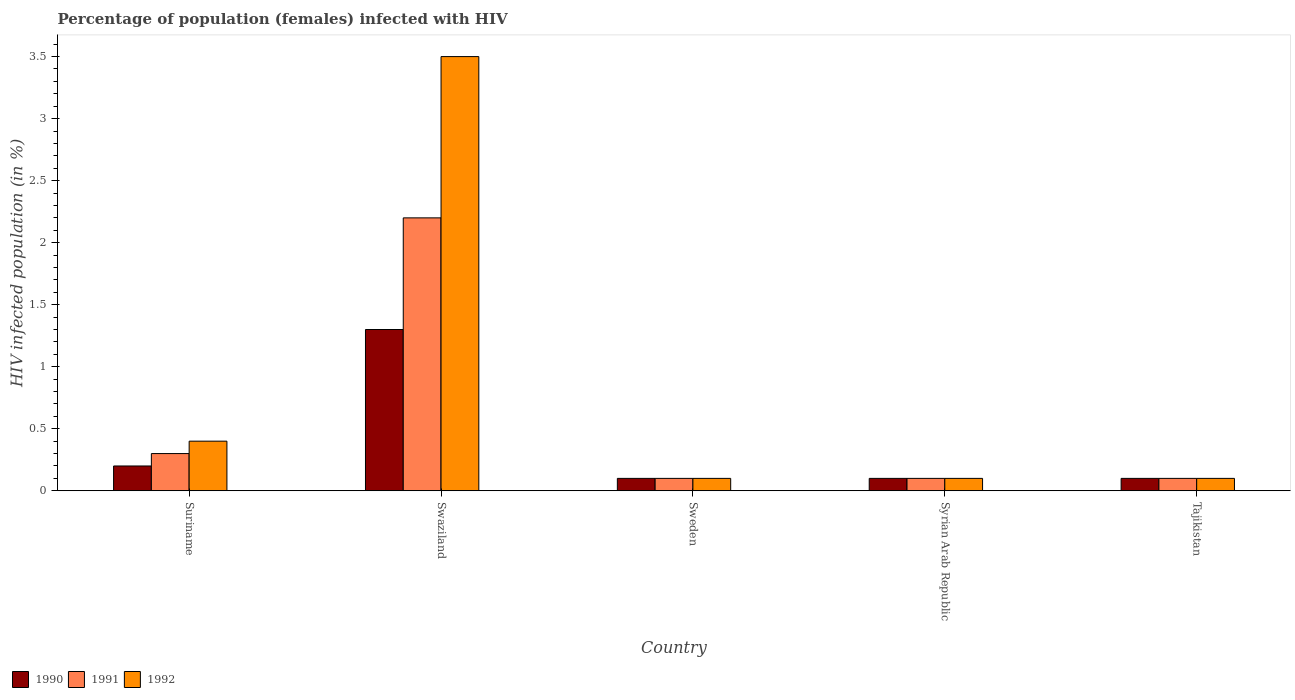How many different coloured bars are there?
Offer a very short reply. 3. How many bars are there on the 2nd tick from the right?
Your response must be concise. 3. What is the label of the 1st group of bars from the left?
Offer a very short reply. Suriname. Across all countries, what is the maximum percentage of HIV infected female population in 1990?
Provide a succinct answer. 1.3. In which country was the percentage of HIV infected female population in 1991 maximum?
Your response must be concise. Swaziland. In which country was the percentage of HIV infected female population in 1990 minimum?
Ensure brevity in your answer.  Sweden. What is the total percentage of HIV infected female population in 1991 in the graph?
Provide a short and direct response. 2.8. What is the average percentage of HIV infected female population in 1991 per country?
Offer a very short reply. 0.56. What is the difference between the percentage of HIV infected female population of/in 1992 and percentage of HIV infected female population of/in 1990 in Sweden?
Provide a succinct answer. 0. In how many countries, is the percentage of HIV infected female population in 1992 greater than 0.9 %?
Provide a short and direct response. 1. Is the percentage of HIV infected female population in 1990 in Sweden less than that in Syrian Arab Republic?
Keep it short and to the point. No. Is the difference between the percentage of HIV infected female population in 1992 in Syrian Arab Republic and Tajikistan greater than the difference between the percentage of HIV infected female population in 1990 in Syrian Arab Republic and Tajikistan?
Offer a terse response. No. What is the difference between the highest and the second highest percentage of HIV infected female population in 1991?
Provide a succinct answer. -1.9. Is the sum of the percentage of HIV infected female population in 1990 in Swaziland and Tajikistan greater than the maximum percentage of HIV infected female population in 1991 across all countries?
Provide a short and direct response. No. What does the 1st bar from the left in Tajikistan represents?
Provide a succinct answer. 1990. What does the 3rd bar from the right in Sweden represents?
Your answer should be compact. 1990. Are all the bars in the graph horizontal?
Your answer should be compact. No. How many countries are there in the graph?
Provide a succinct answer. 5. What is the difference between two consecutive major ticks on the Y-axis?
Provide a short and direct response. 0.5. Does the graph contain any zero values?
Your answer should be compact. No. Where does the legend appear in the graph?
Your response must be concise. Bottom left. How many legend labels are there?
Keep it short and to the point. 3. What is the title of the graph?
Keep it short and to the point. Percentage of population (females) infected with HIV. What is the label or title of the X-axis?
Offer a terse response. Country. What is the label or title of the Y-axis?
Your answer should be compact. HIV infected population (in %). What is the HIV infected population (in %) in 1990 in Suriname?
Your response must be concise. 0.2. What is the HIV infected population (in %) of 1992 in Suriname?
Make the answer very short. 0.4. What is the HIV infected population (in %) in 1992 in Swaziland?
Keep it short and to the point. 3.5. What is the HIV infected population (in %) in 1991 in Sweden?
Your answer should be compact. 0.1. What is the HIV infected population (in %) in 1992 in Sweden?
Your answer should be compact. 0.1. What is the HIV infected population (in %) of 1992 in Syrian Arab Republic?
Provide a succinct answer. 0.1. What is the HIV infected population (in %) of 1990 in Tajikistan?
Keep it short and to the point. 0.1. What is the HIV infected population (in %) in 1992 in Tajikistan?
Provide a short and direct response. 0.1. Across all countries, what is the maximum HIV infected population (in %) of 1992?
Make the answer very short. 3.5. Across all countries, what is the minimum HIV infected population (in %) in 1990?
Make the answer very short. 0.1. Across all countries, what is the minimum HIV infected population (in %) in 1991?
Offer a very short reply. 0.1. What is the total HIV infected population (in %) in 1991 in the graph?
Give a very brief answer. 2.8. What is the total HIV infected population (in %) of 1992 in the graph?
Provide a short and direct response. 4.2. What is the difference between the HIV infected population (in %) of 1992 in Suriname and that in Swaziland?
Ensure brevity in your answer.  -3.1. What is the difference between the HIV infected population (in %) of 1990 in Suriname and that in Sweden?
Your answer should be very brief. 0.1. What is the difference between the HIV infected population (in %) in 1992 in Suriname and that in Sweden?
Make the answer very short. 0.3. What is the difference between the HIV infected population (in %) of 1990 in Suriname and that in Syrian Arab Republic?
Provide a succinct answer. 0.1. What is the difference between the HIV infected population (in %) of 1991 in Suriname and that in Syrian Arab Republic?
Keep it short and to the point. 0.2. What is the difference between the HIV infected population (in %) in 1992 in Suriname and that in Syrian Arab Republic?
Make the answer very short. 0.3. What is the difference between the HIV infected population (in %) of 1990 in Swaziland and that in Sweden?
Your answer should be very brief. 1.2. What is the difference between the HIV infected population (in %) of 1991 in Swaziland and that in Sweden?
Keep it short and to the point. 2.1. What is the difference between the HIV infected population (in %) of 1992 in Swaziland and that in Syrian Arab Republic?
Provide a succinct answer. 3.4. What is the difference between the HIV infected population (in %) in 1991 in Swaziland and that in Tajikistan?
Your response must be concise. 2.1. What is the difference between the HIV infected population (in %) of 1992 in Swaziland and that in Tajikistan?
Your answer should be very brief. 3.4. What is the difference between the HIV infected population (in %) in 1990 in Sweden and that in Syrian Arab Republic?
Keep it short and to the point. 0. What is the difference between the HIV infected population (in %) in 1992 in Sweden and that in Syrian Arab Republic?
Keep it short and to the point. 0. What is the difference between the HIV infected population (in %) of 1990 in Sweden and that in Tajikistan?
Make the answer very short. 0. What is the difference between the HIV infected population (in %) of 1990 in Syrian Arab Republic and that in Tajikistan?
Ensure brevity in your answer.  0. What is the difference between the HIV infected population (in %) in 1990 in Suriname and the HIV infected population (in %) in 1992 in Swaziland?
Your response must be concise. -3.3. What is the difference between the HIV infected population (in %) of 1991 in Suriname and the HIV infected population (in %) of 1992 in Swaziland?
Your response must be concise. -3.2. What is the difference between the HIV infected population (in %) of 1991 in Suriname and the HIV infected population (in %) of 1992 in Sweden?
Provide a short and direct response. 0.2. What is the difference between the HIV infected population (in %) in 1991 in Suriname and the HIV infected population (in %) in 1992 in Tajikistan?
Provide a succinct answer. 0.2. What is the difference between the HIV infected population (in %) in 1990 in Swaziland and the HIV infected population (in %) in 1991 in Sweden?
Make the answer very short. 1.2. What is the difference between the HIV infected population (in %) in 1991 in Swaziland and the HIV infected population (in %) in 1992 in Sweden?
Your response must be concise. 2.1. What is the difference between the HIV infected population (in %) in 1990 in Swaziland and the HIV infected population (in %) in 1992 in Syrian Arab Republic?
Offer a very short reply. 1.2. What is the difference between the HIV infected population (in %) of 1990 in Sweden and the HIV infected population (in %) of 1991 in Syrian Arab Republic?
Your answer should be very brief. 0. What is the difference between the HIV infected population (in %) of 1990 in Sweden and the HIV infected population (in %) of 1992 in Syrian Arab Republic?
Keep it short and to the point. 0. What is the difference between the HIV infected population (in %) in 1990 in Sweden and the HIV infected population (in %) in 1992 in Tajikistan?
Your answer should be compact. 0. What is the difference between the HIV infected population (in %) of 1991 in Sweden and the HIV infected population (in %) of 1992 in Tajikistan?
Provide a succinct answer. 0. What is the difference between the HIV infected population (in %) in 1991 in Syrian Arab Republic and the HIV infected population (in %) in 1992 in Tajikistan?
Ensure brevity in your answer.  0. What is the average HIV infected population (in %) of 1990 per country?
Keep it short and to the point. 0.36. What is the average HIV infected population (in %) of 1991 per country?
Ensure brevity in your answer.  0.56. What is the average HIV infected population (in %) in 1992 per country?
Provide a short and direct response. 0.84. What is the difference between the HIV infected population (in %) in 1990 and HIV infected population (in %) in 1992 in Suriname?
Ensure brevity in your answer.  -0.2. What is the difference between the HIV infected population (in %) in 1991 and HIV infected population (in %) in 1992 in Suriname?
Offer a very short reply. -0.1. What is the difference between the HIV infected population (in %) of 1990 and HIV infected population (in %) of 1992 in Swaziland?
Keep it short and to the point. -2.2. What is the difference between the HIV infected population (in %) of 1990 and HIV infected population (in %) of 1991 in Sweden?
Provide a succinct answer. 0. What is the difference between the HIV infected population (in %) of 1990 and HIV infected population (in %) of 1992 in Sweden?
Offer a very short reply. 0. What is the difference between the HIV infected population (in %) of 1990 and HIV infected population (in %) of 1992 in Syrian Arab Republic?
Give a very brief answer. 0. What is the difference between the HIV infected population (in %) of 1990 and HIV infected population (in %) of 1991 in Tajikistan?
Keep it short and to the point. 0. What is the difference between the HIV infected population (in %) in 1990 and HIV infected population (in %) in 1992 in Tajikistan?
Your answer should be very brief. 0. What is the ratio of the HIV infected population (in %) of 1990 in Suriname to that in Swaziland?
Your response must be concise. 0.15. What is the ratio of the HIV infected population (in %) of 1991 in Suriname to that in Swaziland?
Provide a short and direct response. 0.14. What is the ratio of the HIV infected population (in %) in 1992 in Suriname to that in Swaziland?
Your response must be concise. 0.11. What is the ratio of the HIV infected population (in %) in 1991 in Suriname to that in Sweden?
Provide a succinct answer. 3. What is the ratio of the HIV infected population (in %) in 1992 in Suriname to that in Sweden?
Keep it short and to the point. 4. What is the ratio of the HIV infected population (in %) of 1990 in Suriname to that in Syrian Arab Republic?
Your answer should be very brief. 2. What is the ratio of the HIV infected population (in %) of 1991 in Suriname to that in Syrian Arab Republic?
Your response must be concise. 3. What is the ratio of the HIV infected population (in %) in 1992 in Suriname to that in Syrian Arab Republic?
Offer a very short reply. 4. What is the ratio of the HIV infected population (in %) in 1990 in Suriname to that in Tajikistan?
Give a very brief answer. 2. What is the ratio of the HIV infected population (in %) in 1992 in Suriname to that in Tajikistan?
Keep it short and to the point. 4. What is the ratio of the HIV infected population (in %) in 1990 in Swaziland to that in Sweden?
Ensure brevity in your answer.  13. What is the ratio of the HIV infected population (in %) of 1991 in Swaziland to that in Sweden?
Keep it short and to the point. 22. What is the ratio of the HIV infected population (in %) in 1991 in Swaziland to that in Syrian Arab Republic?
Ensure brevity in your answer.  22. What is the ratio of the HIV infected population (in %) of 1992 in Swaziland to that in Syrian Arab Republic?
Offer a terse response. 35. What is the ratio of the HIV infected population (in %) of 1990 in Swaziland to that in Tajikistan?
Offer a terse response. 13. What is the ratio of the HIV infected population (in %) in 1991 in Sweden to that in Syrian Arab Republic?
Keep it short and to the point. 1. What is the ratio of the HIV infected population (in %) of 1992 in Sweden to that in Syrian Arab Republic?
Provide a short and direct response. 1. What is the ratio of the HIV infected population (in %) of 1990 in Sweden to that in Tajikistan?
Give a very brief answer. 1. What is the ratio of the HIV infected population (in %) of 1991 in Sweden to that in Tajikistan?
Your answer should be very brief. 1. What is the ratio of the HIV infected population (in %) in 1991 in Syrian Arab Republic to that in Tajikistan?
Your answer should be very brief. 1. What is the ratio of the HIV infected population (in %) in 1992 in Syrian Arab Republic to that in Tajikistan?
Make the answer very short. 1. What is the difference between the highest and the second highest HIV infected population (in %) in 1991?
Your answer should be very brief. 1.9. What is the difference between the highest and the lowest HIV infected population (in %) in 1990?
Your answer should be very brief. 1.2. What is the difference between the highest and the lowest HIV infected population (in %) of 1992?
Make the answer very short. 3.4. 